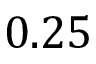<formula> <loc_0><loc_0><loc_500><loc_500>0 . 2 5</formula> 